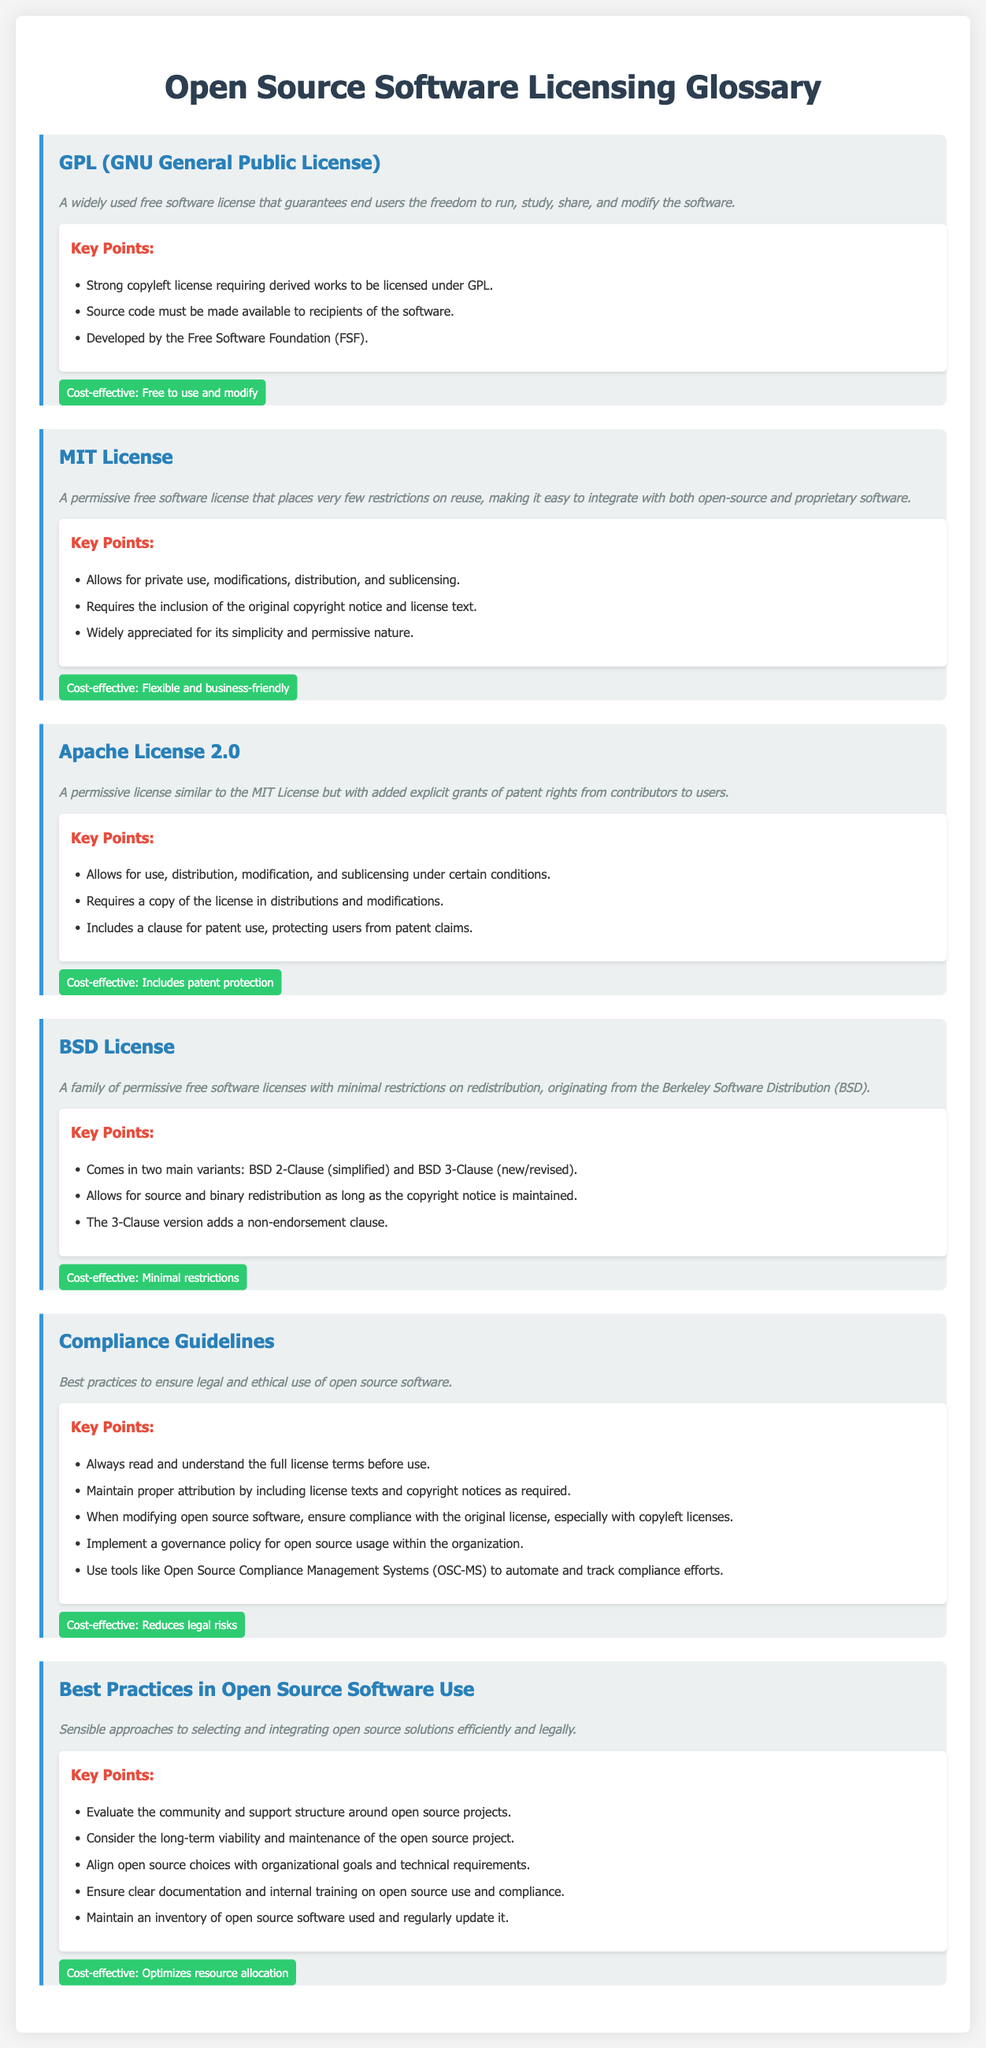What is GPL? GPL is a widely used free software license that guarantees end users the freedom to run, study, share, and modify the software.
Answer: A widely used free software license What type of license is the MIT License? The MIT License is a permissive free software license that places very few restrictions on reuse.
Answer: Permissive free software license What is a requirement of the Apache License 2.0? A requirement of the Apache License 2.0 is to include a copy of the license in distributions and modifications.
Answer: Include a copy of the license What does the BSD License family originate from? The BSD License family originates from the Berkeley Software Distribution.
Answer: Berkeley Software Distribution What does "strong copyleft" mean in the context of GPL? "Strong copyleft" in the context of GPL means that derived works must be licensed under GPL.
Answer: Derived works must be licensed under GPL What are the key points in the compliance guidelines? The key points in the compliance guidelines include reading the full license terms, maintaining proper attribution, and ensuring compliance when modifying software.
Answer: Read the full license terms What is one best practice for using open source software? One best practice for using open source software is to evaluate the community and support structure around open source projects.
Answer: Evaluate the community and support structure What is the cost-effective aspect of compliance guidelines? The cost-effective aspect of compliance guidelines is that it reduces legal risks.
Answer: Reduces legal risks Which license offers patent protection to users? The Apache License 2.0 offers patent protection to users.
Answer: Apache License 2.0 What are the two main variants of the BSD License? The two main variants of the BSD License are BSD 2-Clause and BSD 3-Clause.
Answer: BSD 2-Clause and BSD 3-Clause 